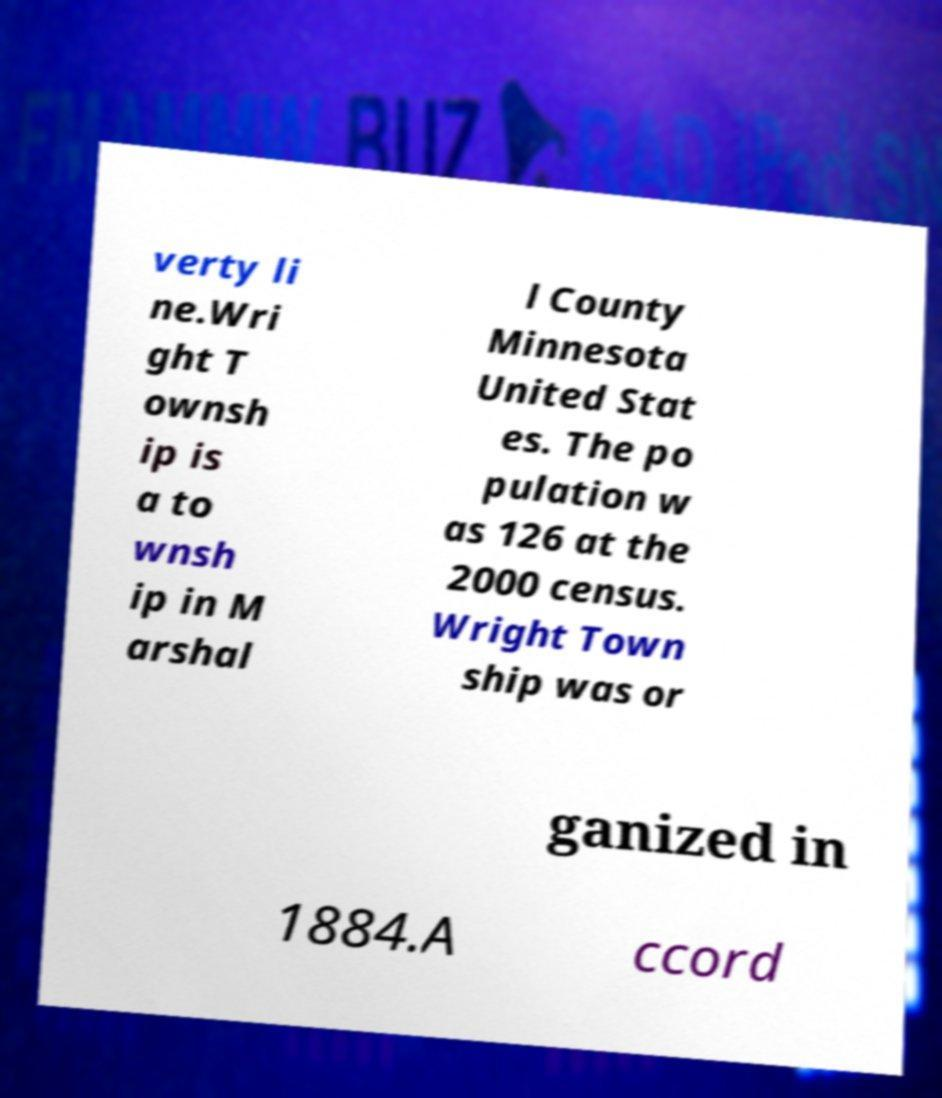Please read and relay the text visible in this image. What does it say? verty li ne.Wri ght T ownsh ip is a to wnsh ip in M arshal l County Minnesota United Stat es. The po pulation w as 126 at the 2000 census. Wright Town ship was or ganized in 1884.A ccord 